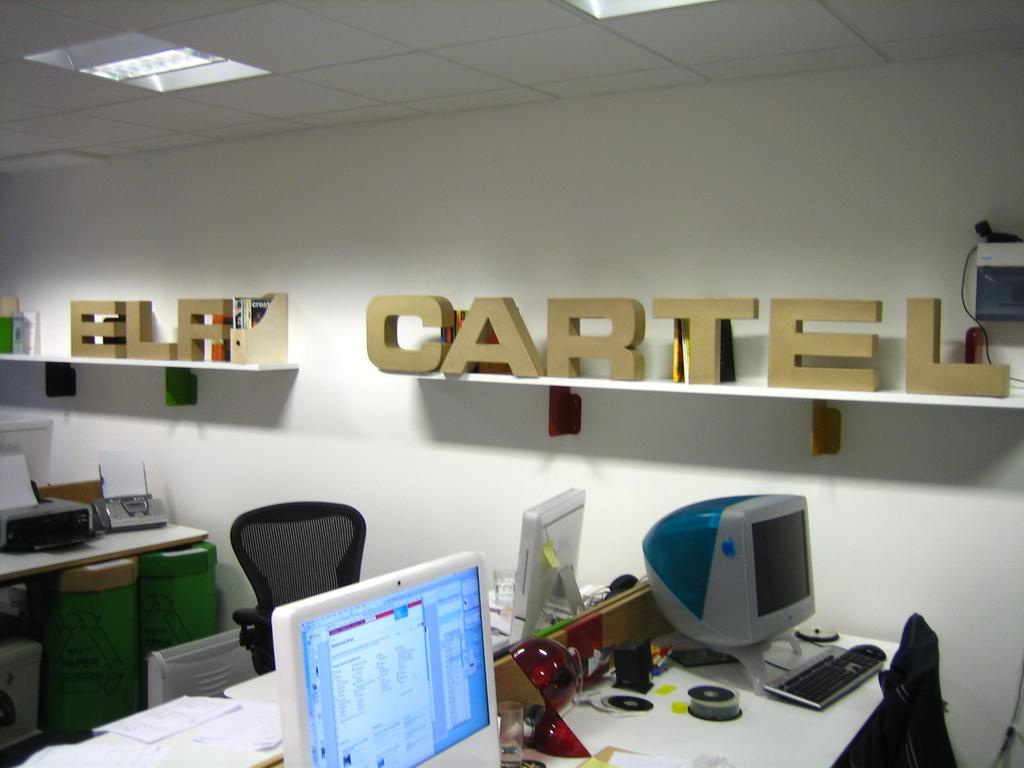<image>
Write a terse but informative summary of the picture. Elf Cartel fixtures are sitting on white shelves on the wall. 